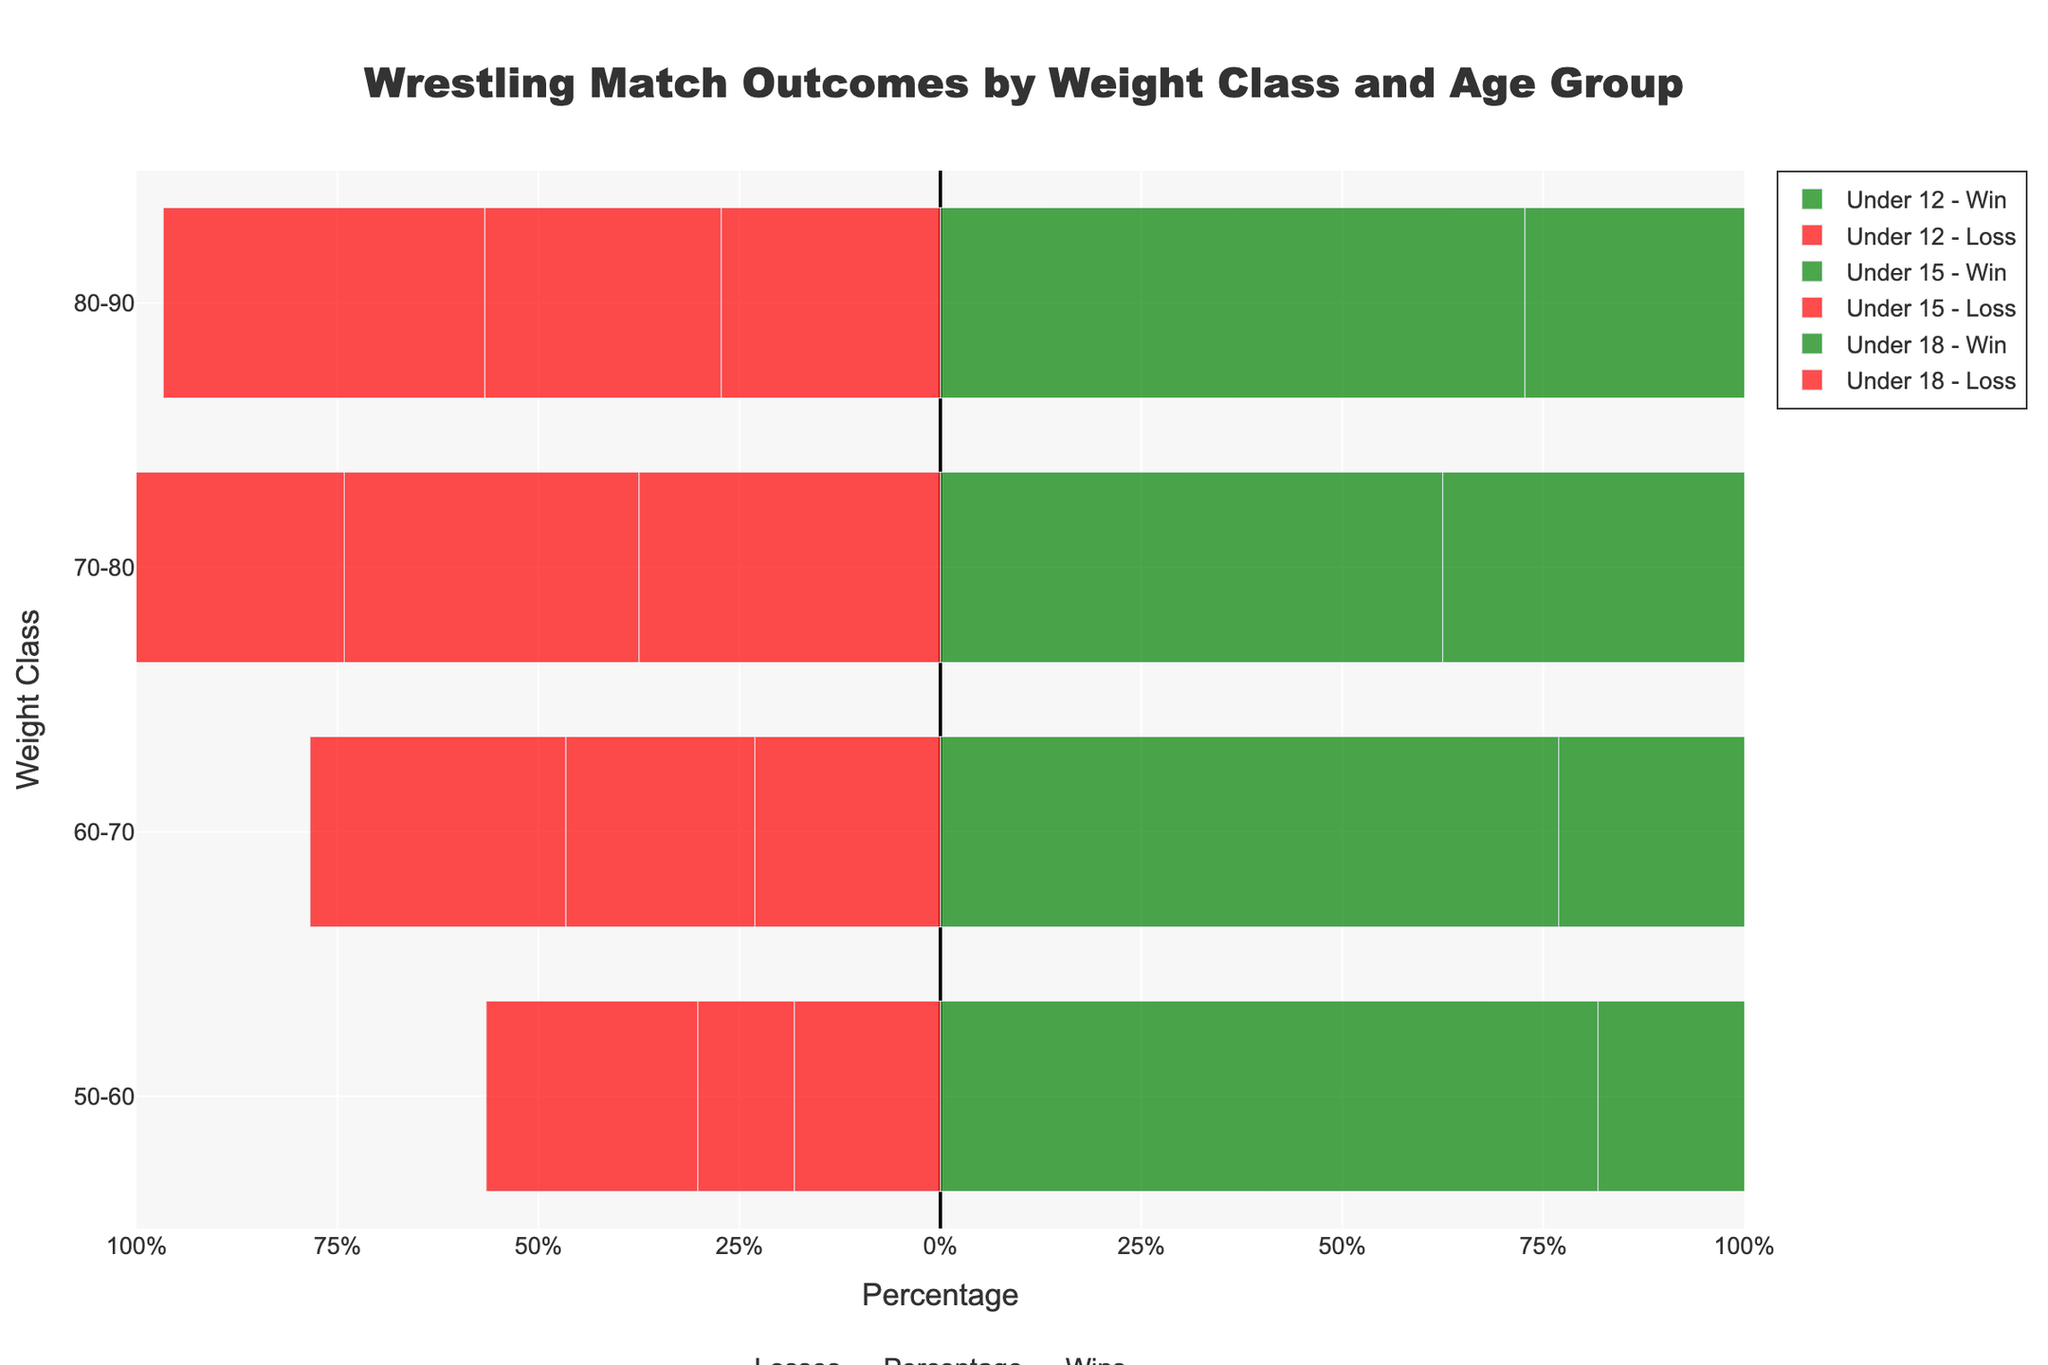Which age group has the highest win percentage in the 50-60 weight class? First, look for the 50-60 weight class across all age groups. Then compare the win percentages by observing the length of the green bars. The Under 18 group has the longest green bar, indicating the highest win percentage.
Answer: Under 18 Which age group sees the greatest imbalance between wins and losses in the 60-70 weight class? Evaluate the differences in the lengths of the green (wins) and red (losses) bars in the 60-70 weight class for each age group. The Under 15 group shows the greatest difference, with a much longer green bar compared to the red bar.
Answer: Under 15 Across all age groups, which weight class has the closest win-loss ratio? Find the weight class where the lengths of the green and red bars are closest together, indicating a balanced win-loss distribution. For the 70-80 weight class in the Under 12 group, the green and red bars are nearly equal in length.
Answer: 70-80 (Under 12) Which age group and weight class combination has the lowest total number of matches? Check the hover information for each bar for the total number of matches (sum of wins and losses). The Under 12 group in the 80-90 weight class has the fewest total matches: 8 wins and 3 losses equalling 11 matches.
Answer: Under 12, 80-90 How many more wins than losses does the Under 18 age group have in the 80-90 weight class? Look at the hover information for the Under 18 group in the 80-90 weight class. They have 18 wins and 12 losses. The difference is 18 - 12 = 6.
Answer: 6 In the 50-60 weight class, does any age group win more than 75% of their matches? Check each age group's win percentage for the 50-60 weight class. The Under 15 and Under 18 groups show win percentages higher than 75% in this category.
Answer: Yes Between the Under 15 and Under 18 age groups, which has a higher win percentage in the 70-80 weight class? Compare the lengths of the green bars (win percentages) for the 70-80 weight class in the Under 15 and Under 18 groups. The Under 15 group has a shorter green bar, thus a lower win percentage than the Under 18 group.
Answer: Under 18 Which age group has the most wins overall? Sum up the win counts from the hover information for each age group. The Under 18 group has the highest total wins across all weight classes.
Answer: Under 18 